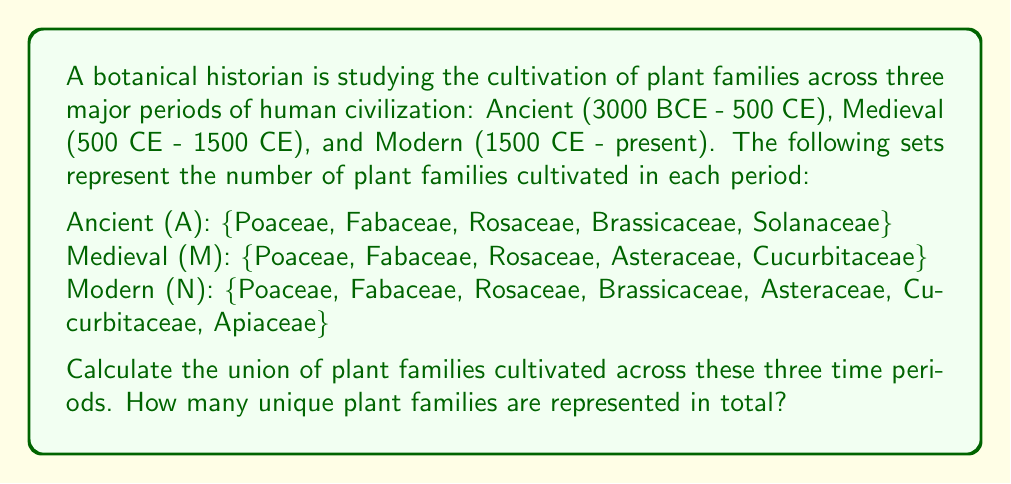Provide a solution to this math problem. To solve this problem, we need to find the union of the three sets A, M, and N, which we can denote as $A \cup M \cup N$. The union of these sets will include all unique elements that appear in at least one of the sets.

Let's break down the process step-by-step:

1. First, let's list all the unique plant families across all three sets:
   - Poaceae
   - Fabaceae
   - Rosaceae
   - Brassicaceae
   - Solanaceae
   - Asteraceae
   - Cucurbitaceae
   - Apiaceae

2. Now, let's check which families appear in each set:
   - Poaceae: appears in A, M, and N
   - Fabaceae: appears in A, M, and N
   - Rosaceae: appears in A, M, and N
   - Brassicaceae: appears in A and N
   - Solanaceae: appears in A only
   - Asteraceae: appears in M and N
   - Cucurbitaceae: appears in M and N
   - Apiaceae: appears in N only

3. The union of these sets includes all unique elements, regardless of how many sets they appear in. Therefore, $A \cup M \cup N$ includes all 8 plant families listed above.

4. To find the total number of unique plant families, we simply count the elements in the union set, which is 8.

This result shows how plant cultivation has evolved over time, with some families being consistently important (like Poaceae, Fabaceae, and Rosaceae), while others were introduced or gained prominence in later periods (like Apiaceae in the Modern era).
Answer: The union of plant families cultivated across the Ancient, Medieval, and Modern periods is:

$A \cup M \cup N = \{$Poaceae, Fabaceae, Rosaceae, Brassicaceae, Solanaceae, Asteraceae, Cucurbitaceae, Apiaceae$\}$

The total number of unique plant families represented is 8. 